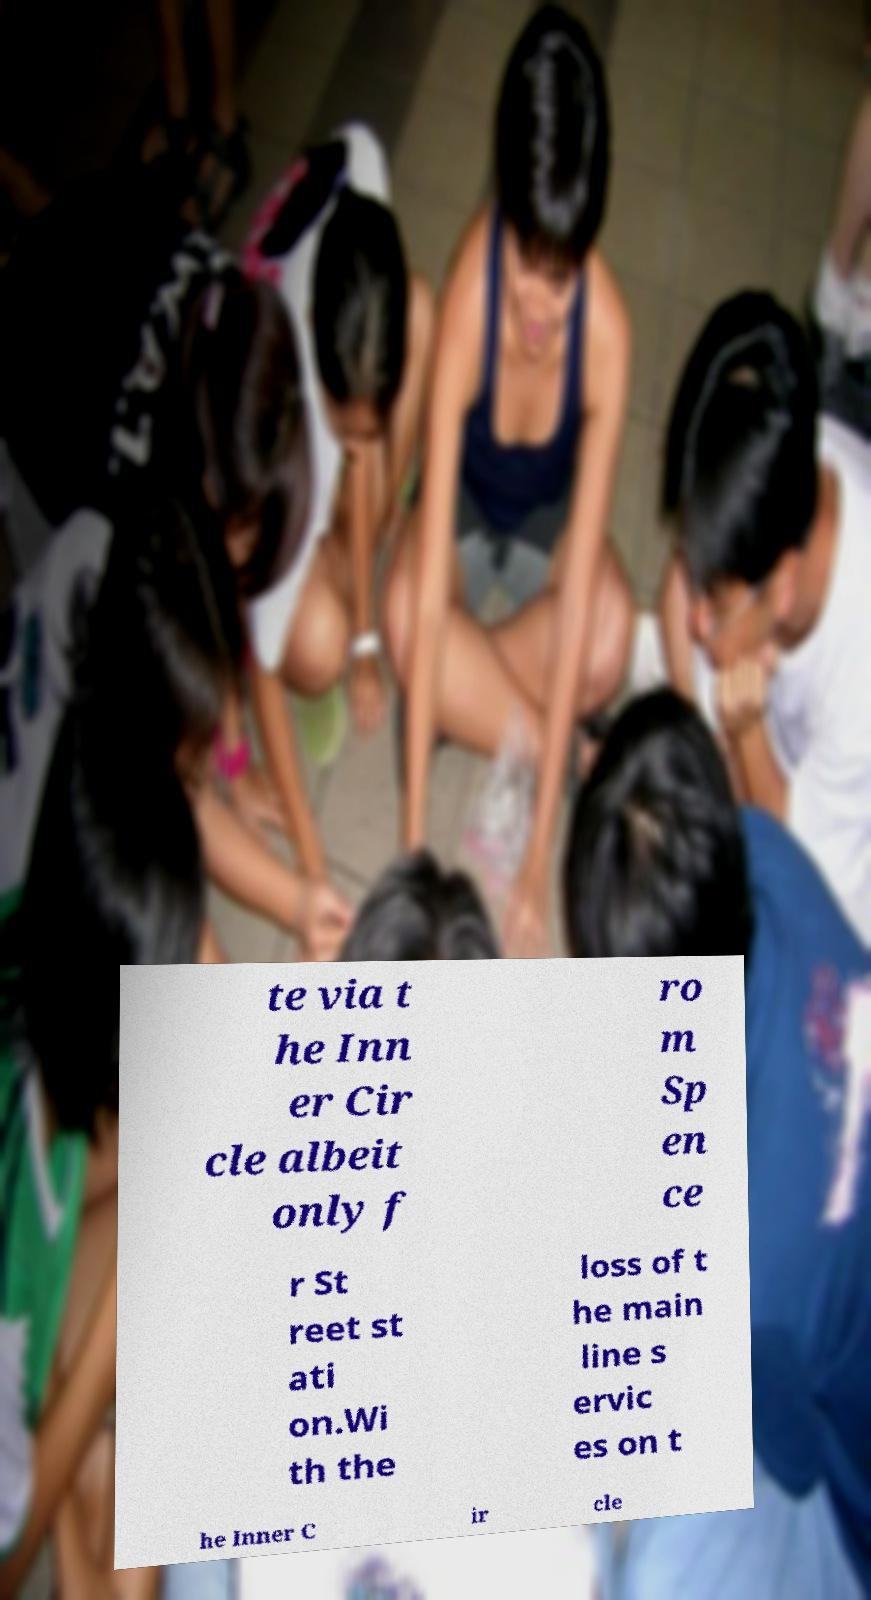I need the written content from this picture converted into text. Can you do that? te via t he Inn er Cir cle albeit only f ro m Sp en ce r St reet st ati on.Wi th the loss of t he main line s ervic es on t he Inner C ir cle 